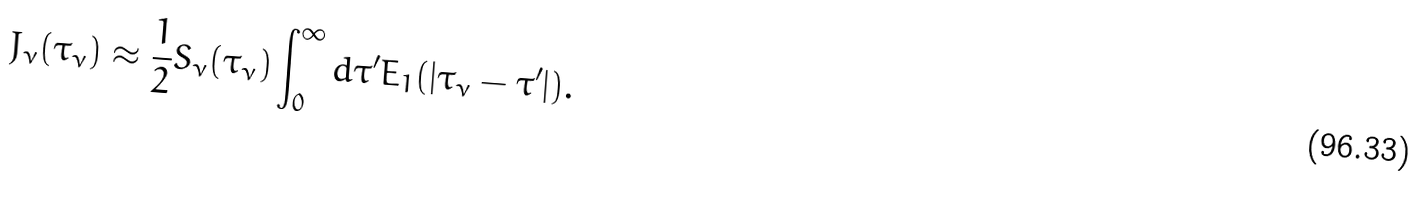<formula> <loc_0><loc_0><loc_500><loc_500>J _ { \nu } ( \tau _ { \nu } ) \approx \frac { 1 } { 2 } S _ { \nu } ( \tau _ { \nu } ) \int _ { 0 } ^ { \infty } d \tau ^ { \prime } E _ { 1 } ( | \tau _ { \nu } - \tau ^ { \prime } | ) .</formula> 